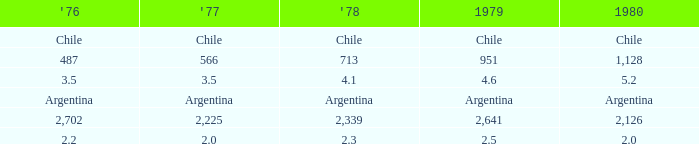What is 1977 when 1978 is 4.1? 3.5. 